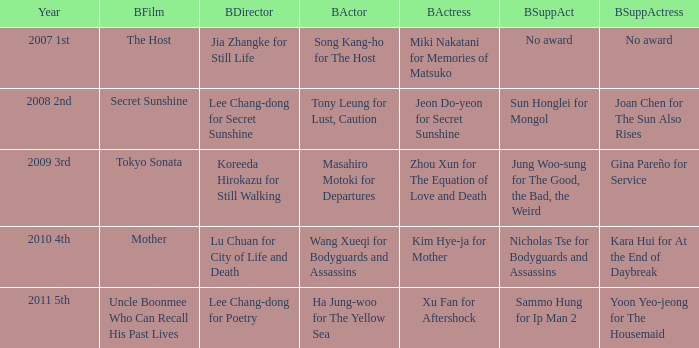Name the best actor for uncle boonmee who can recall his past lives Ha Jung-woo for The Yellow Sea. Would you mind parsing the complete table? {'header': ['Year', 'BFilm', 'BDirector', 'BActor', 'BActress', 'BSuppAct', 'BSuppActress'], 'rows': [['2007 1st', 'The Host', 'Jia Zhangke for Still Life', 'Song Kang-ho for The Host', 'Miki Nakatani for Memories of Matsuko', 'No award', 'No award'], ['2008 2nd', 'Secret Sunshine', 'Lee Chang-dong for Secret Sunshine', 'Tony Leung for Lust, Caution', 'Jeon Do-yeon for Secret Sunshine', 'Sun Honglei for Mongol', 'Joan Chen for The Sun Also Rises'], ['2009 3rd', 'Tokyo Sonata', 'Koreeda Hirokazu for Still Walking', 'Masahiro Motoki for Departures', 'Zhou Xun for The Equation of Love and Death', 'Jung Woo-sung for The Good, the Bad, the Weird', 'Gina Pareño for Service'], ['2010 4th', 'Mother', 'Lu Chuan for City of Life and Death', 'Wang Xueqi for Bodyguards and Assassins', 'Kim Hye-ja for Mother', 'Nicholas Tse for Bodyguards and Assassins', 'Kara Hui for At the End of Daybreak'], ['2011 5th', 'Uncle Boonmee Who Can Recall His Past Lives', 'Lee Chang-dong for Poetry', 'Ha Jung-woo for The Yellow Sea', 'Xu Fan for Aftershock', 'Sammo Hung for Ip Man 2', 'Yoon Yeo-jeong for The Housemaid']]} 